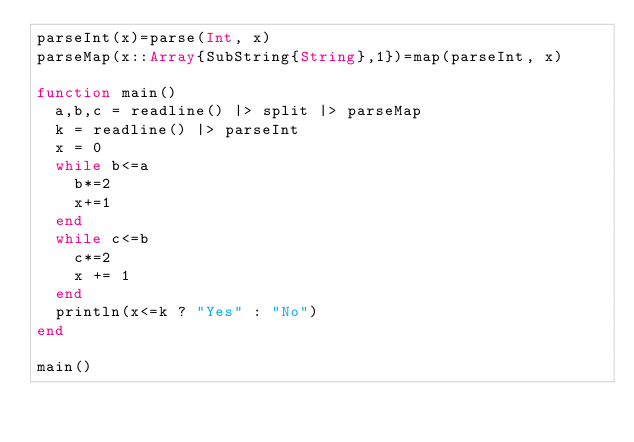<code> <loc_0><loc_0><loc_500><loc_500><_Julia_>parseInt(x)=parse(Int, x)
parseMap(x::Array{SubString{String},1})=map(parseInt, x)

function main()
	a,b,c = readline() |> split |> parseMap
	k = readline() |> parseInt
	x = 0
	while b<=a
		b*=2
		x+=1
	end
	while c<=b
		c*=2
		x += 1
	end
	println(x<=k ? "Yes" : "No")
end

main()</code> 